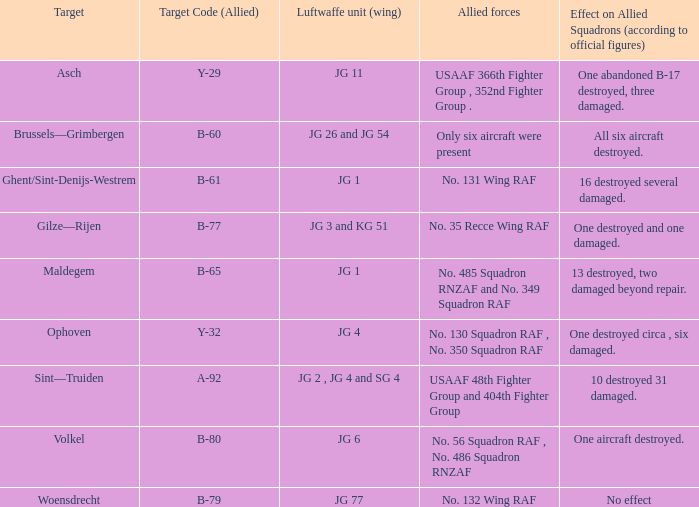Which Allied Force targetted Woensdrecht? No. 132 Wing RAF. Parse the full table. {'header': ['Target', 'Target Code (Allied)', 'Luftwaffe unit (wing)', 'Allied forces', 'Effect on Allied Squadrons (according to official figures)'], 'rows': [['Asch', 'Y-29', 'JG 11', 'USAAF 366th Fighter Group , 352nd Fighter Group .', 'One abandoned B-17 destroyed, three damaged.'], ['Brussels—Grimbergen', 'B-60', 'JG 26 and JG 54', 'Only six aircraft were present', 'All six aircraft destroyed.'], ['Ghent/Sint-Denijs-Westrem', 'B-61', 'JG 1', 'No. 131 Wing RAF', '16 destroyed several damaged.'], ['Gilze—Rijen', 'B-77', 'JG 3 and KG 51', 'No. 35 Recce Wing RAF', 'One destroyed and one damaged.'], ['Maldegem', 'B-65', 'JG 1', 'No. 485 Squadron RNZAF and No. 349 Squadron RAF', '13 destroyed, two damaged beyond repair.'], ['Ophoven', 'Y-32', 'JG 4', 'No. 130 Squadron RAF , No. 350 Squadron RAF', 'One destroyed circa , six damaged.'], ['Sint—Truiden', 'A-92', 'JG 2 , JG 4 and SG 4', 'USAAF 48th Fighter Group and 404th Fighter Group', '10 destroyed 31 damaged.'], ['Volkel', 'B-80', 'JG 6', 'No. 56 Squadron RAF , No. 486 Squadron RNZAF', 'One aircraft destroyed.'], ['Woensdrecht', 'B-79', 'JG 77', 'No. 132 Wing RAF', 'No effect']]} 